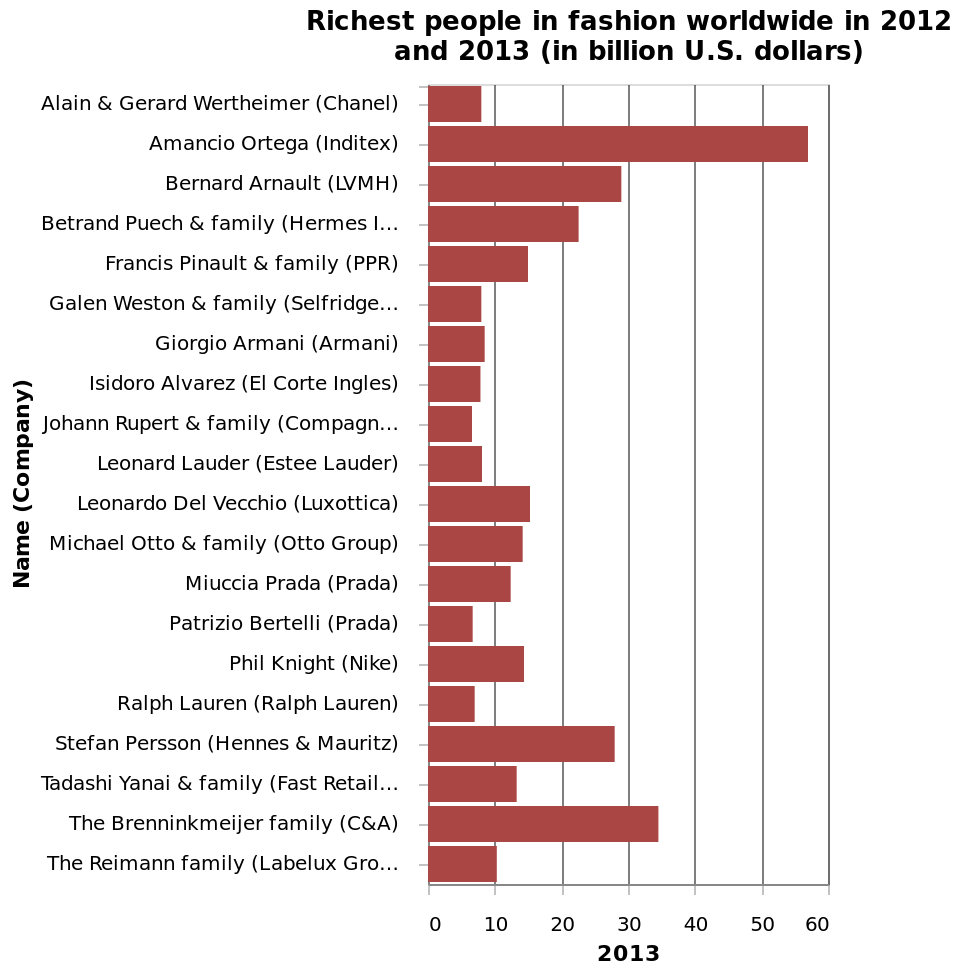<image>
What percentage of fashion companies have a wealth under 10 billion? Approximately 80% of fashion companies have a wealth under 10 billion. 